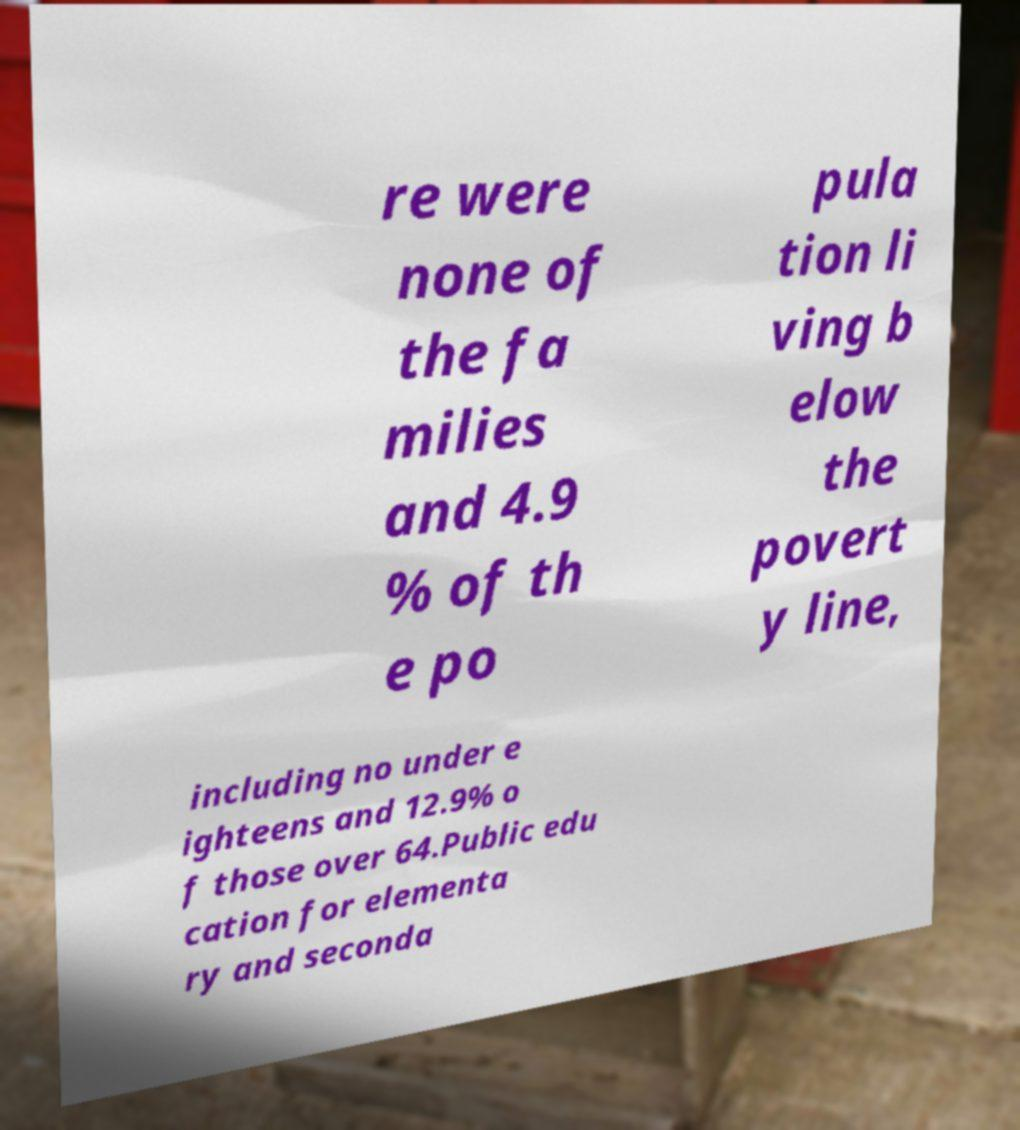For documentation purposes, I need the text within this image transcribed. Could you provide that? re were none of the fa milies and 4.9 % of th e po pula tion li ving b elow the povert y line, including no under e ighteens and 12.9% o f those over 64.Public edu cation for elementa ry and seconda 